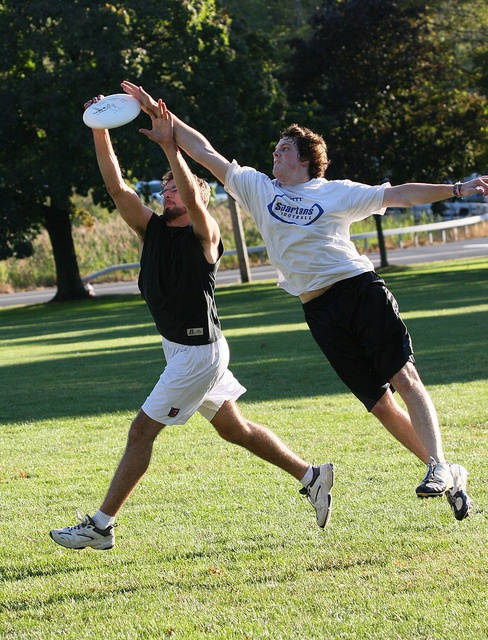Describe the objects in this image and their specific colors. I can see people in black, darkgray, gray, and white tones, people in black, maroon, darkgray, and gray tones, and frisbee in black, lightblue, darkgray, and lavender tones in this image. 